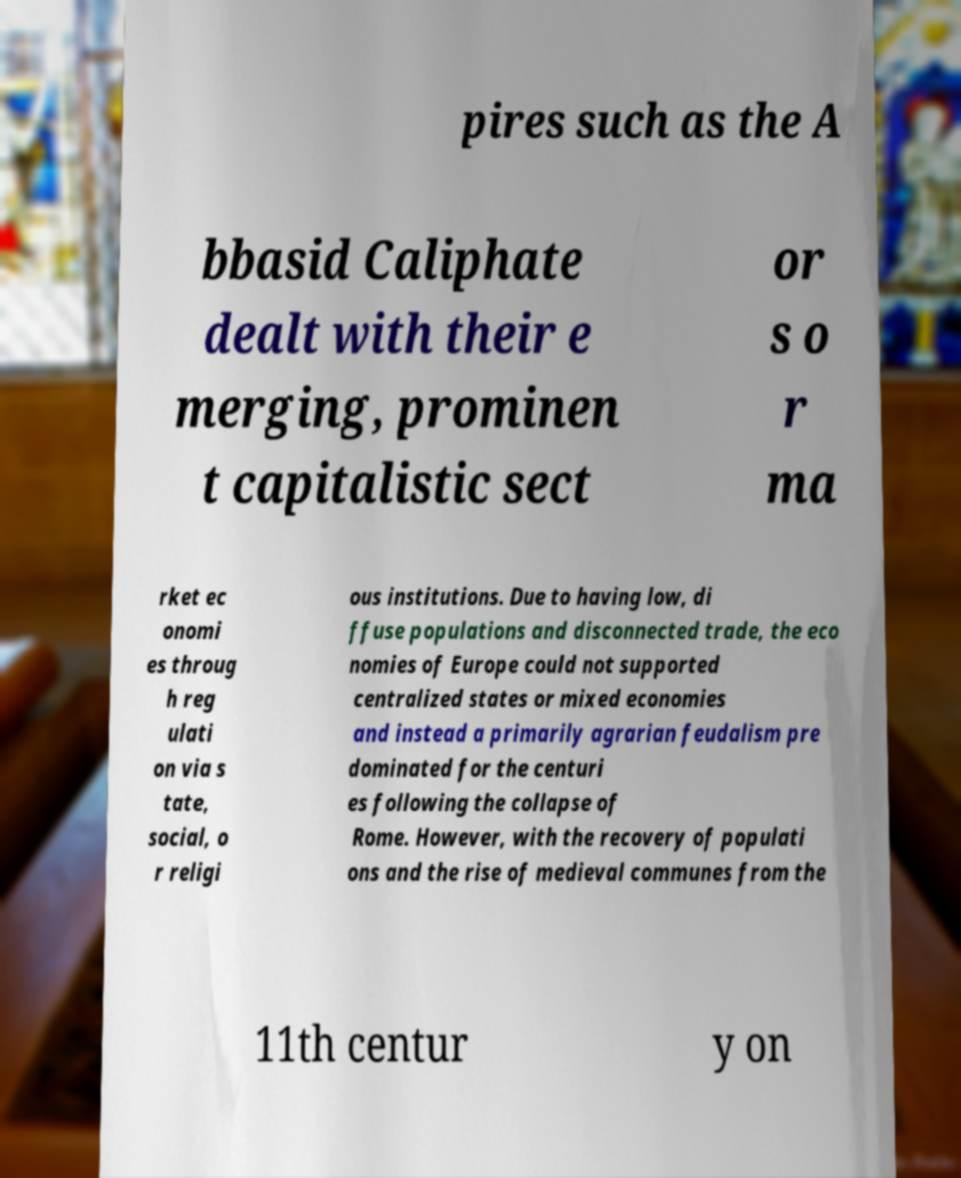Can you accurately transcribe the text from the provided image for me? pires such as the A bbasid Caliphate dealt with their e merging, prominen t capitalistic sect or s o r ma rket ec onomi es throug h reg ulati on via s tate, social, o r religi ous institutions. Due to having low, di ffuse populations and disconnected trade, the eco nomies of Europe could not supported centralized states or mixed economies and instead a primarily agrarian feudalism pre dominated for the centuri es following the collapse of Rome. However, with the recovery of populati ons and the rise of medieval communes from the 11th centur y on 